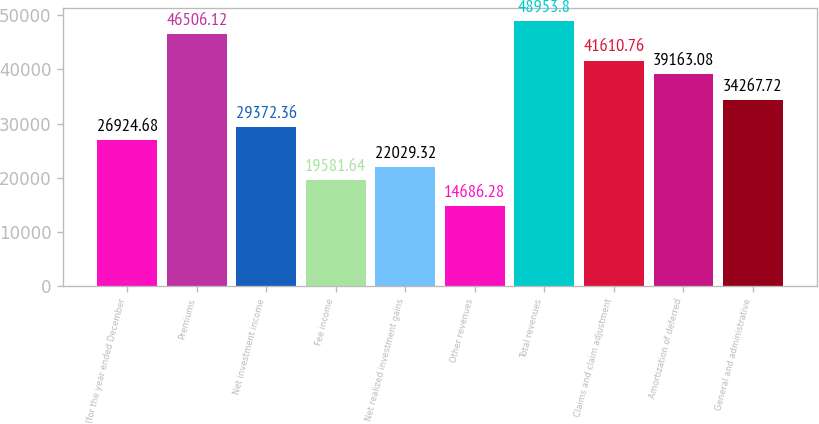<chart> <loc_0><loc_0><loc_500><loc_500><bar_chart><fcel>(for the year ended December<fcel>Premiums<fcel>Net investment income<fcel>Fee income<fcel>Net realized investment gains<fcel>Other revenues<fcel>Total revenues<fcel>Claims and claim adjustment<fcel>Amortization of deferred<fcel>General and administrative<nl><fcel>26924.7<fcel>46506.1<fcel>29372.4<fcel>19581.6<fcel>22029.3<fcel>14686.3<fcel>48953.8<fcel>41610.8<fcel>39163.1<fcel>34267.7<nl></chart> 